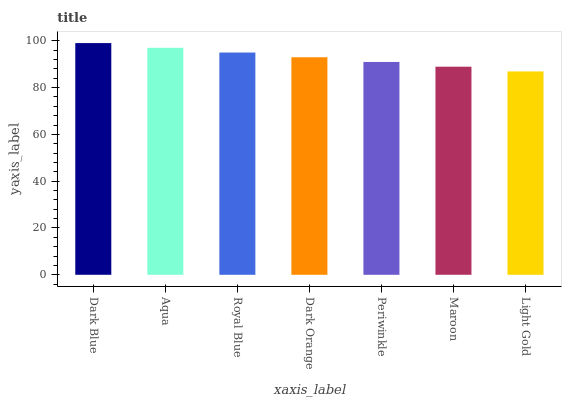Is Light Gold the minimum?
Answer yes or no. Yes. Is Dark Blue the maximum?
Answer yes or no. Yes. Is Aqua the minimum?
Answer yes or no. No. Is Aqua the maximum?
Answer yes or no. No. Is Dark Blue greater than Aqua?
Answer yes or no. Yes. Is Aqua less than Dark Blue?
Answer yes or no. Yes. Is Aqua greater than Dark Blue?
Answer yes or no. No. Is Dark Blue less than Aqua?
Answer yes or no. No. Is Dark Orange the high median?
Answer yes or no. Yes. Is Dark Orange the low median?
Answer yes or no. Yes. Is Light Gold the high median?
Answer yes or no. No. Is Aqua the low median?
Answer yes or no. No. 